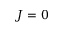Convert formula to latex. <formula><loc_0><loc_0><loc_500><loc_500>J = 0</formula> 